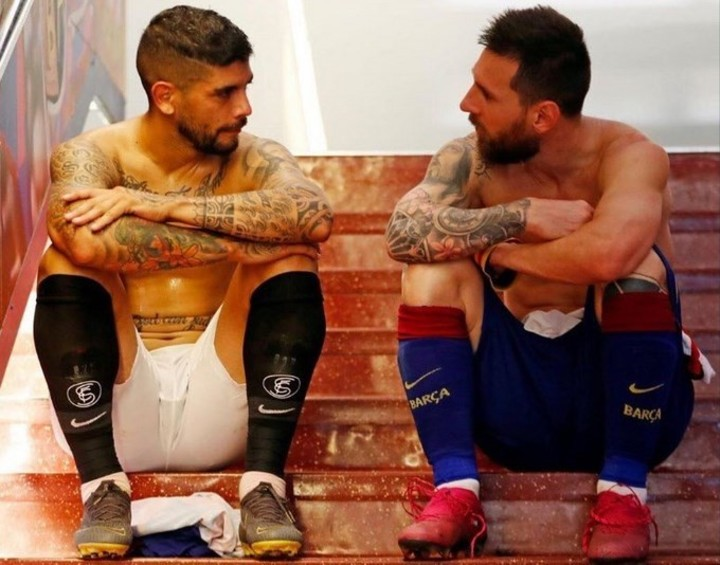Can you describe the emotions the players might be feeling? The players might be experiencing a mix of emotions, including contemplation, determination, and perhaps a hint of frustration. The player on the left, with his reflective posture and downward gaze, seems to be deep in thought, possibly analyzing his performance or reflecting on a recent experience. The player on the right, with his thoughtful gesture of hand to mouth, appears to be in a moment of concern or introspection as well. They might be feeling the weight of their roles and responsibilities, sharing a moment of silent support and understanding as they navigate their sporting journeys together. What do you think is the significance of their tattoos in this context? The tattoos on the players could symbolize personal beliefs, significant events, or sources of inspiration that are meaningful to them both on and off the field. In this context, their tattoos might reflect their journeys, struggles, and triumphs, serving as visual reminders of their past experiences and motivations. The intricate and diverse designs could also symbolize their strength and resilience, emphasizing their individuality and personal stories. The presence of these tattoos in such a contemplative moment suggests that their identities and personal histories are an integral part of their professional lives and their determination to succeed. Imagine a whimsical twist: what if they are actually discussing their favorite comic books? In a whimsical twist, the two players might be passionately discussing their favorite comic books, comparing storylines, characters, and plot twists. The player on the left could be recounting an epic battle scene from a superhero comic, while the player on the right is deeply immersed in describing the latest adventures of his favorite anti-hero. Their gestures and expressions might indicate excitement and engagement as they debate the best story arcs and predict future developments. This shared interest in comic books could be a way for them to bond over something unrelated to their sport, providing a mental escape and a source of joy and inspiration amidst their athletic careers. Realistically, what life advice could they be sharing? Realistically, the players might be sharing life advice about balancing their professional and personal lives, handling pressure, and staying grounded amidst success and challenges. They could be discussing the importance of staying focused on their goals, maintaining a strong work ethic, and supporting each other through the ups and downs of their careers. The conversation might also include advice on dealing with injuries, managing stress, and finding ways to stay motivated. By offering each other guidance and encouragement, they reinforce the idea that despite the competitive nature of their sport, mutual support and understanding are crucial for personal and professional growth. 